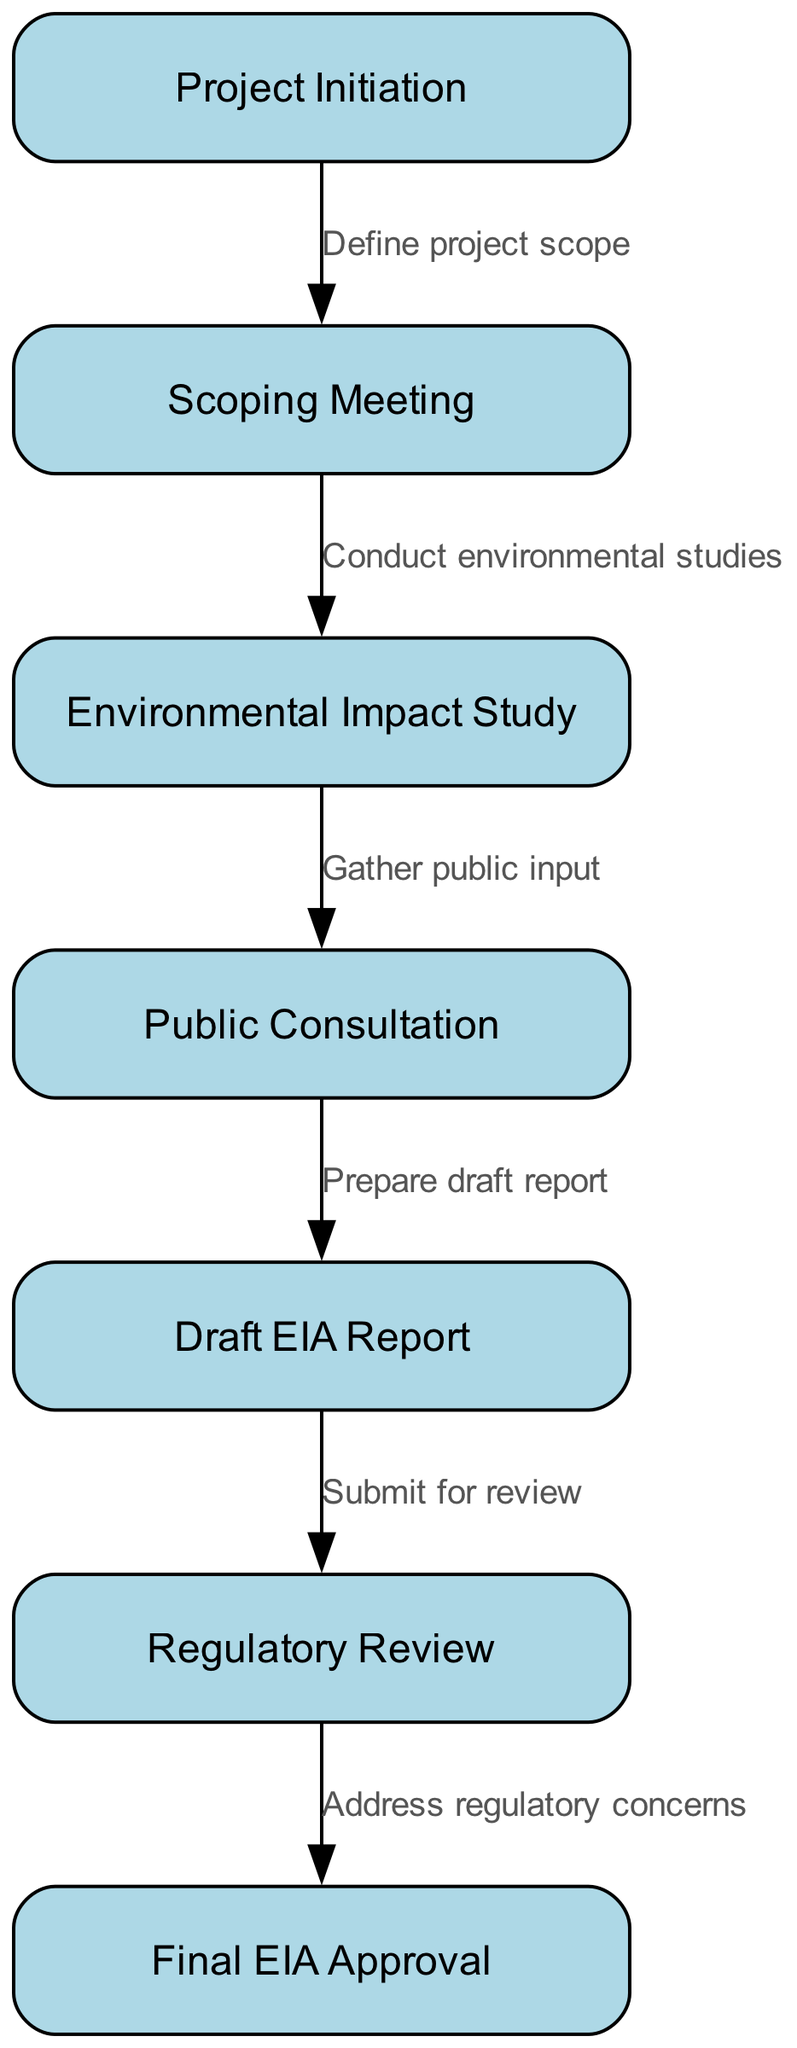What is the starting point of the environmental impact assessment process? The first node in the diagram represents the starting point of the process, which is "Project Initiation."
Answer: Project Initiation How many nodes are present in the diagram? The diagram lists a total of 7 nodes representing different stages of the environmental impact assessment process.
Answer: 7 What is the relationship between "Scoping Meeting" and "Environmental Impact Study"? The edge connecting these two nodes indicates that the "Scoping Meeting" leads to the "Environmental Impact Study," with the explanation "Conduct environmental studies."
Answer: Conduct environmental studies What comes after the "Public Consultation"? The next step in the process, which follows "Public Consultation," is the preparation of the "Draft EIA Report." The edge shows this sequential relationship.
Answer: Draft EIA Report Which node is directly connected to "Regulatory Review"? The node that directly precedes "Regulatory Review" is "Draft EIA Report," indicating it is the step that leads into the review process as noted by the edge.
Answer: Draft EIA Report What is the final step in the process? The final node indicated in the diagram is "Final EIA Approval," which marks the completion of the environmental impact assessment process.
Answer: Final EIA Approval What step involves gathering public input? The "Public Consultation" node signifies the stage where public input is gathered within the environmental impact assessment process.
Answer: Public Consultation What must be addressed after the "Regulatory Review"? The edge from "Regulatory Review" to "Final EIA Approval" states that "Address regulatory concerns" is required after the review before final approval can be obtained.
Answer: Address regulatory concerns What is the primary purpose of the initial "Project Initiation"? The purpose of the "Project Initiation" node is indicated as defining the scope of the assessment process, according to its connection with the subsequent "Scoping Meeting."
Answer: Define project scope 